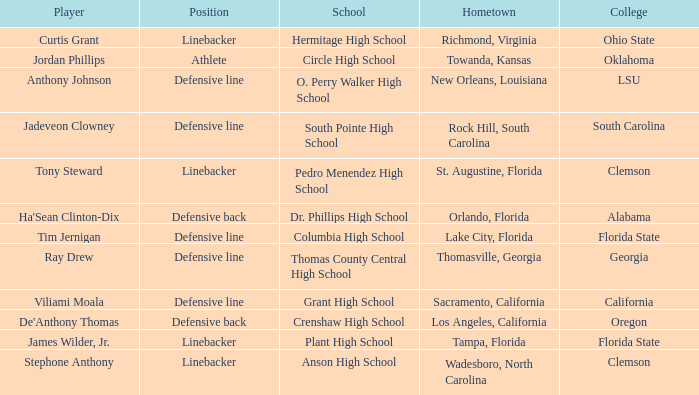What position is for Plant high school? Linebacker. 